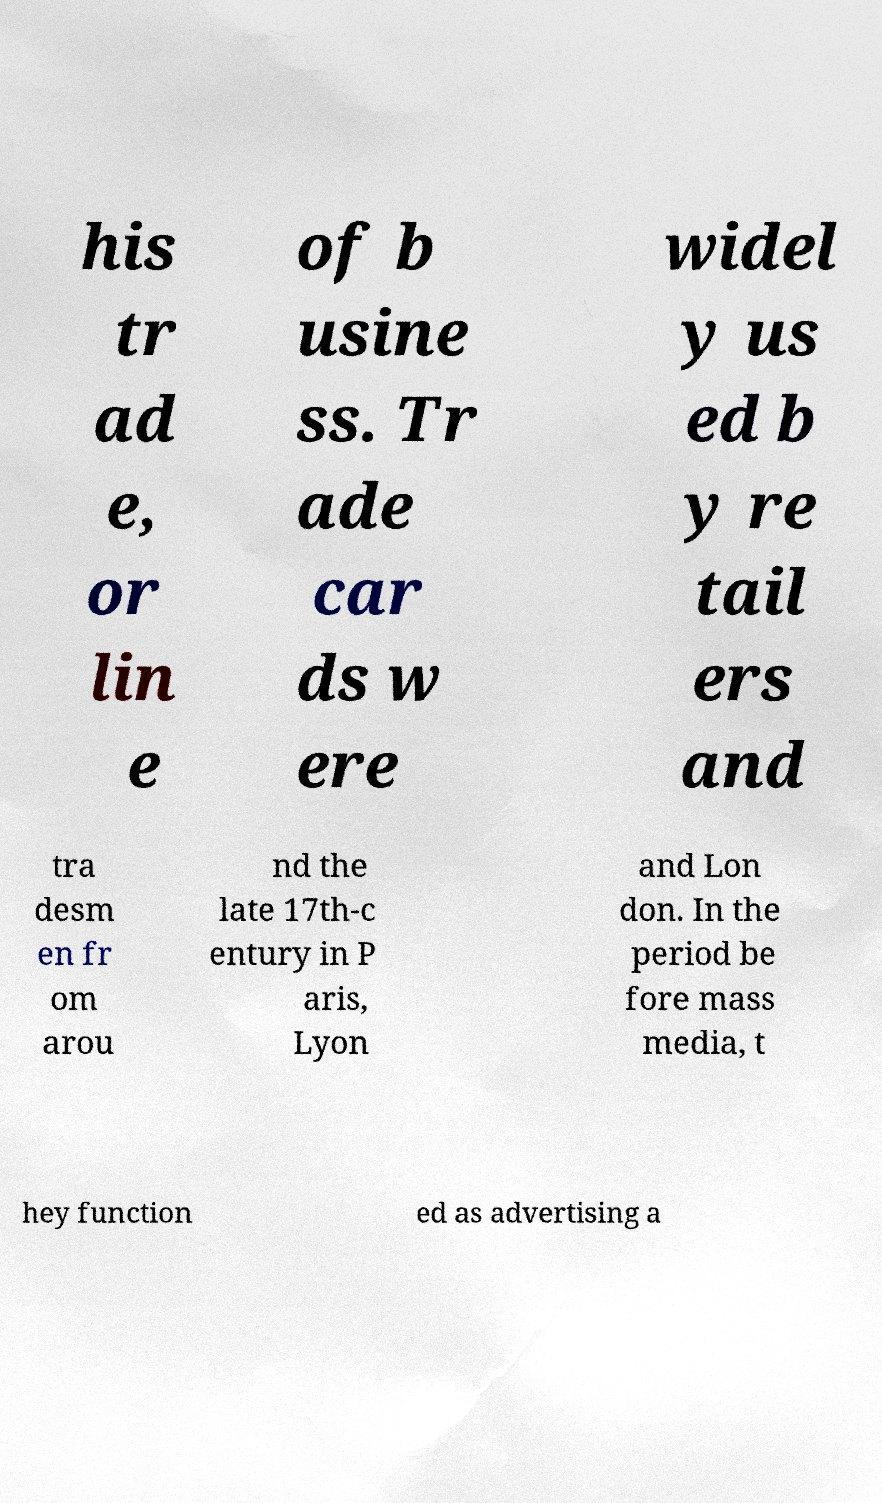For documentation purposes, I need the text within this image transcribed. Could you provide that? his tr ad e, or lin e of b usine ss. Tr ade car ds w ere widel y us ed b y re tail ers and tra desm en fr om arou nd the late 17th-c entury in P aris, Lyon and Lon don. In the period be fore mass media, t hey function ed as advertising a 